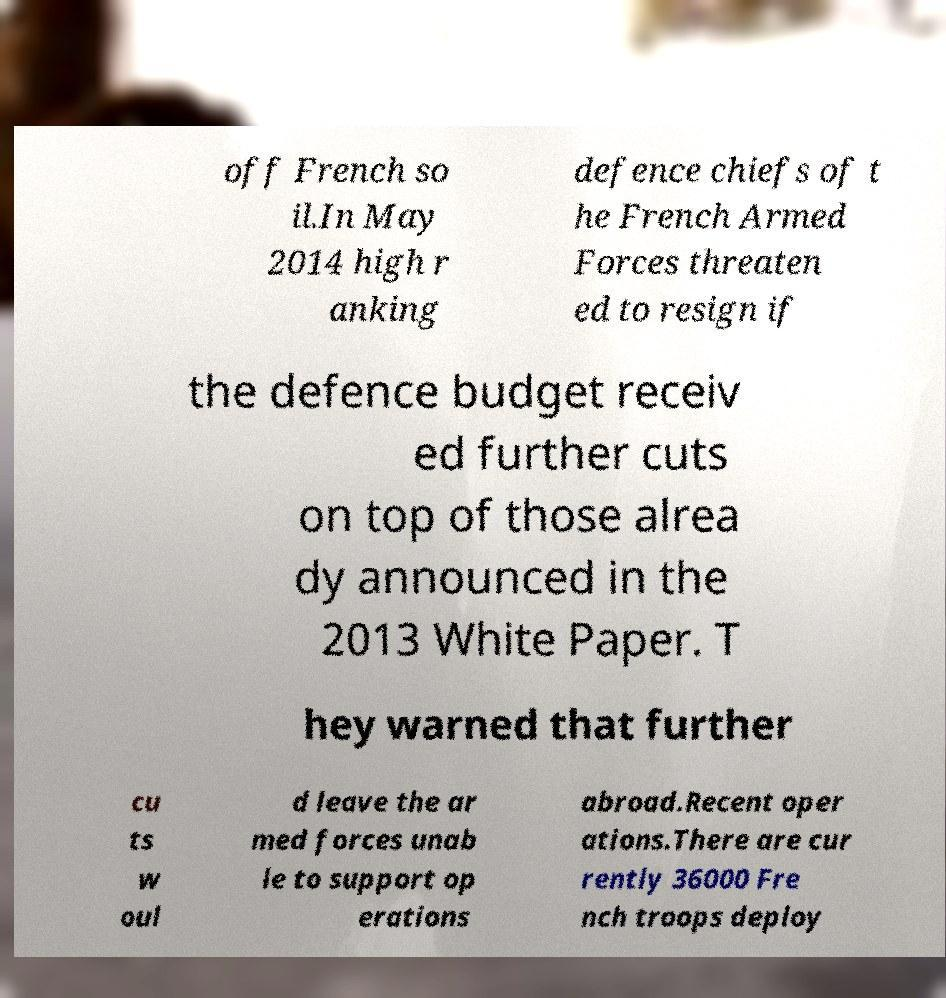For documentation purposes, I need the text within this image transcribed. Could you provide that? off French so il.In May 2014 high r anking defence chiefs of t he French Armed Forces threaten ed to resign if the defence budget receiv ed further cuts on top of those alrea dy announced in the 2013 White Paper. T hey warned that further cu ts w oul d leave the ar med forces unab le to support op erations abroad.Recent oper ations.There are cur rently 36000 Fre nch troops deploy 